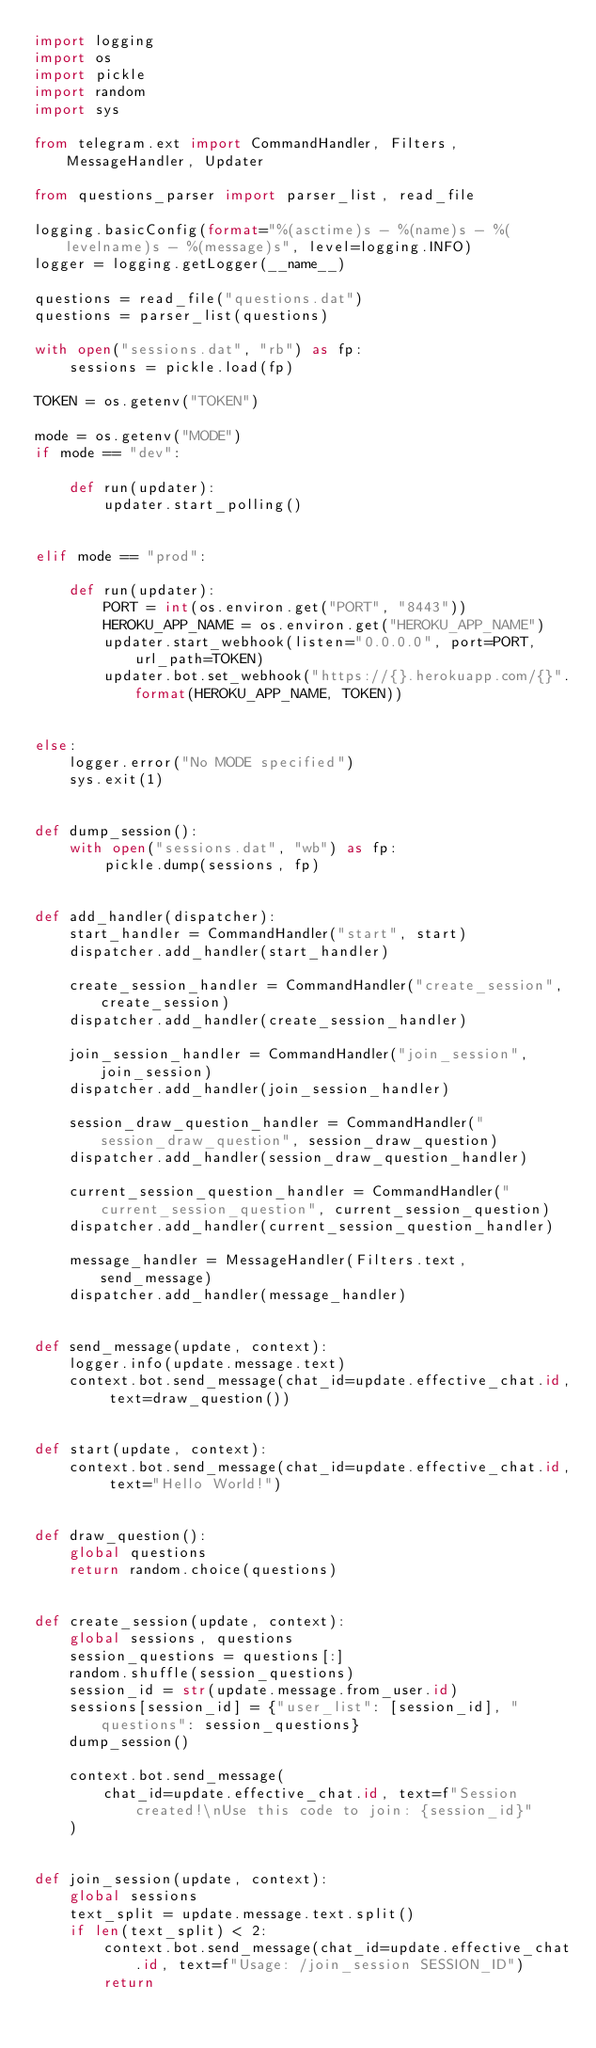<code> <loc_0><loc_0><loc_500><loc_500><_Python_>import logging
import os
import pickle
import random
import sys

from telegram.ext import CommandHandler, Filters, MessageHandler, Updater

from questions_parser import parser_list, read_file

logging.basicConfig(format="%(asctime)s - %(name)s - %(levelname)s - %(message)s", level=logging.INFO)
logger = logging.getLogger(__name__)

questions = read_file("questions.dat")
questions = parser_list(questions)

with open("sessions.dat", "rb") as fp:
    sessions = pickle.load(fp)

TOKEN = os.getenv("TOKEN")

mode = os.getenv("MODE")
if mode == "dev":

    def run(updater):
        updater.start_polling()


elif mode == "prod":

    def run(updater):
        PORT = int(os.environ.get("PORT", "8443"))
        HEROKU_APP_NAME = os.environ.get("HEROKU_APP_NAME")
        updater.start_webhook(listen="0.0.0.0", port=PORT, url_path=TOKEN)
        updater.bot.set_webhook("https://{}.herokuapp.com/{}".format(HEROKU_APP_NAME, TOKEN))


else:
    logger.error("No MODE specified")
    sys.exit(1)


def dump_session():
    with open("sessions.dat", "wb") as fp:
        pickle.dump(sessions, fp)


def add_handler(dispatcher):
    start_handler = CommandHandler("start", start)
    dispatcher.add_handler(start_handler)

    create_session_handler = CommandHandler("create_session", create_session)
    dispatcher.add_handler(create_session_handler)

    join_session_handler = CommandHandler("join_session", join_session)
    dispatcher.add_handler(join_session_handler)

    session_draw_question_handler = CommandHandler("session_draw_question", session_draw_question)
    dispatcher.add_handler(session_draw_question_handler)

    current_session_question_handler = CommandHandler("current_session_question", current_session_question)
    dispatcher.add_handler(current_session_question_handler)

    message_handler = MessageHandler(Filters.text, send_message)
    dispatcher.add_handler(message_handler)


def send_message(update, context):
    logger.info(update.message.text)
    context.bot.send_message(chat_id=update.effective_chat.id, text=draw_question())


def start(update, context):
    context.bot.send_message(chat_id=update.effective_chat.id, text="Hello World!")


def draw_question():
    global questions
    return random.choice(questions)


def create_session(update, context):
    global sessions, questions
    session_questions = questions[:]
    random.shuffle(session_questions)
    session_id = str(update.message.from_user.id)
    sessions[session_id] = {"user_list": [session_id], "questions": session_questions}
    dump_session()

    context.bot.send_message(
        chat_id=update.effective_chat.id, text=f"Session created!\nUse this code to join: {session_id}"
    )


def join_session(update, context):
    global sessions
    text_split = update.message.text.split()
    if len(text_split) < 2:
        context.bot.send_message(chat_id=update.effective_chat.id, text=f"Usage: /join_session SESSION_ID")
        return</code> 